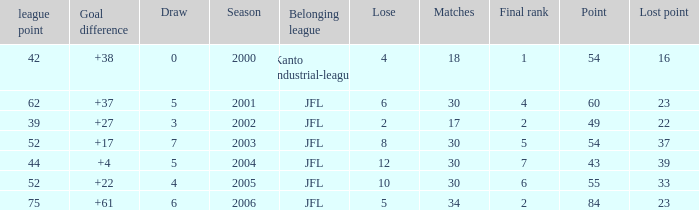Could you parse the entire table as a dict? {'header': ['league point', 'Goal difference', 'Draw', 'Season', 'Belonging league', 'Lose', 'Matches', 'Final rank', 'Point', 'Lost point'], 'rows': [['42', '+38', '0', '2000', 'Kanto industrial-league', '4', '18', '1', '54', '16'], ['62', '+37', '5', '2001', 'JFL', '6', '30', '4', '60', '23'], ['39', '+27', '3', '2002', 'JFL', '2', '17', '2', '49', '22'], ['52', '+17', '7', '2003', 'JFL', '8', '30', '5', '54', '37'], ['44', '+4', '5', '2004', 'JFL', '12', '30', '7', '43', '39'], ['52', '+22', '4', '2005', 'JFL', '10', '30', '6', '55', '33'], ['75', '+61', '6', '2006', 'JFL', '5', '34', '2', '84', '23']]} Tell me the highest point with lost point being 33 and league point less than 52 None. 